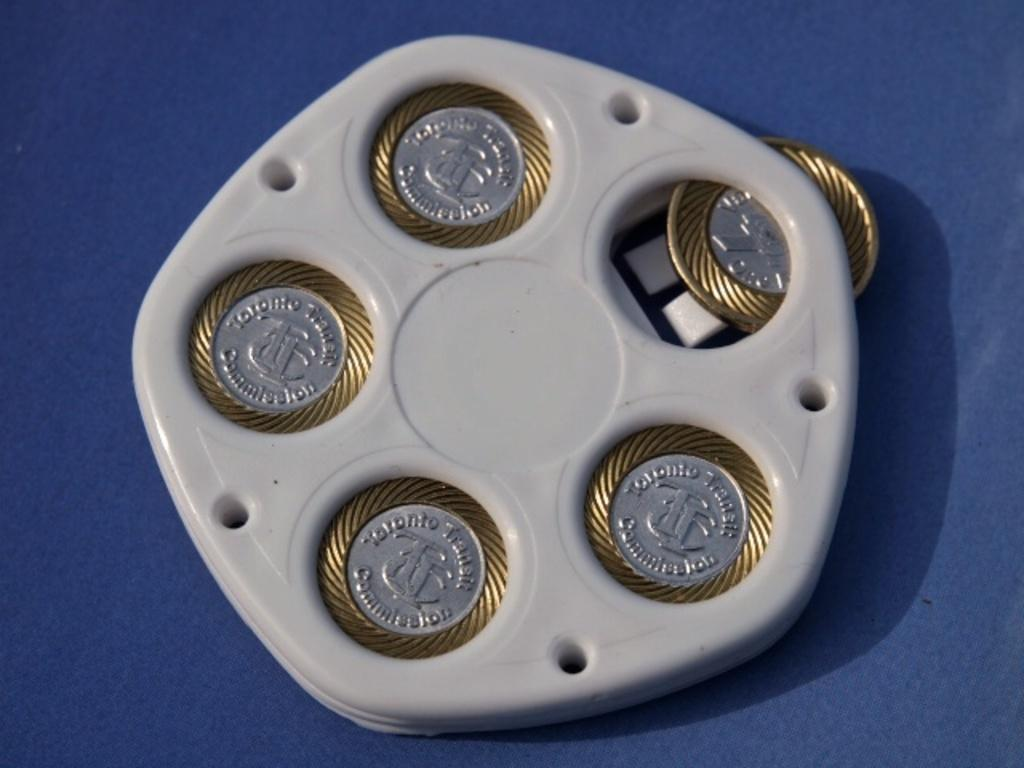What is the white object in the image containing coins? There are coins in a white object in the image. What color is the surface that can be seen in the image? There is a blue surface in the image. How many basketballs can be seen on the blue surface in the image? There are no basketballs present in the image; it only features coins in a white object and a blue surface. 